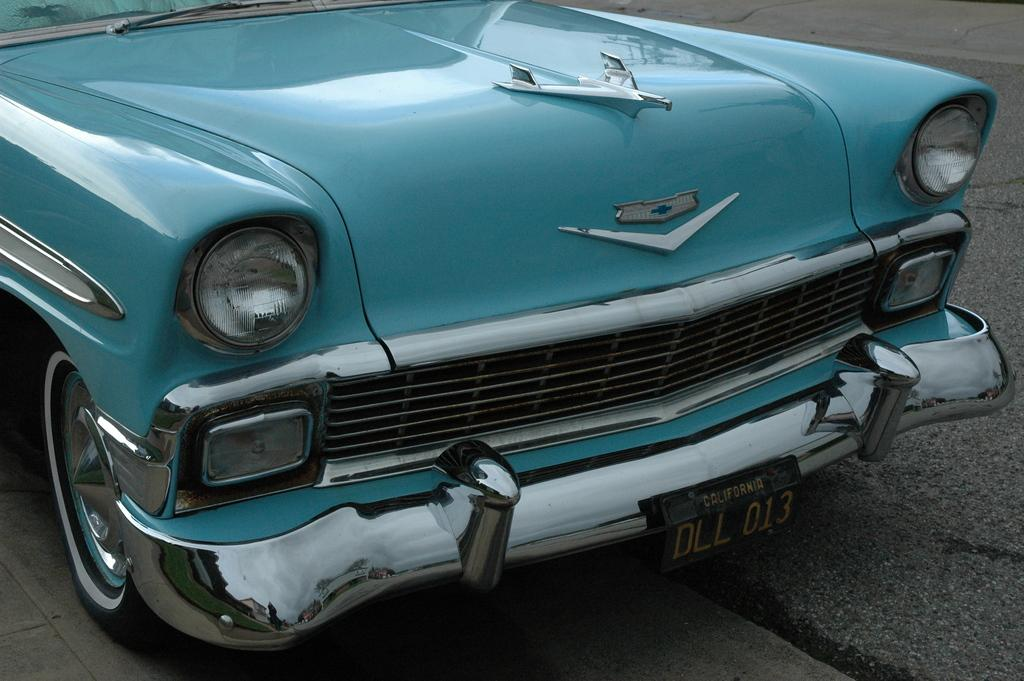What is the main subject of the image? The main subject of the image is a car. Where is the car located in the image? The car is on the road in the image. How close is the car to the viewer in the image? The car is in the foreground of the image, which means it is close to the viewer. What type of crime is being committed by the ship in the image? There is no ship present in the image, and therefore no crime can be committed by a ship. 